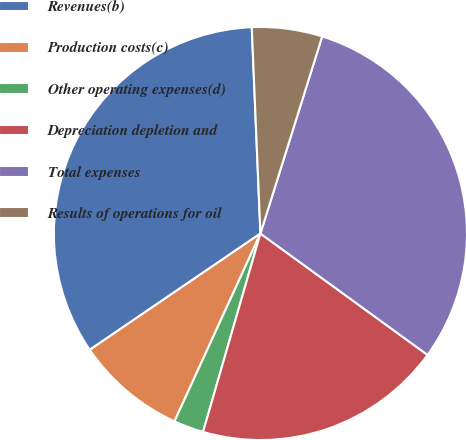Convert chart to OTSL. <chart><loc_0><loc_0><loc_500><loc_500><pie_chart><fcel>Revenues(b)<fcel>Production costs(c)<fcel>Other operating expenses(d)<fcel>Depreciation depletion and<fcel>Total expenses<fcel>Results of operations for oil<nl><fcel>33.85%<fcel>8.65%<fcel>2.35%<fcel>19.48%<fcel>30.16%<fcel>5.5%<nl></chart> 